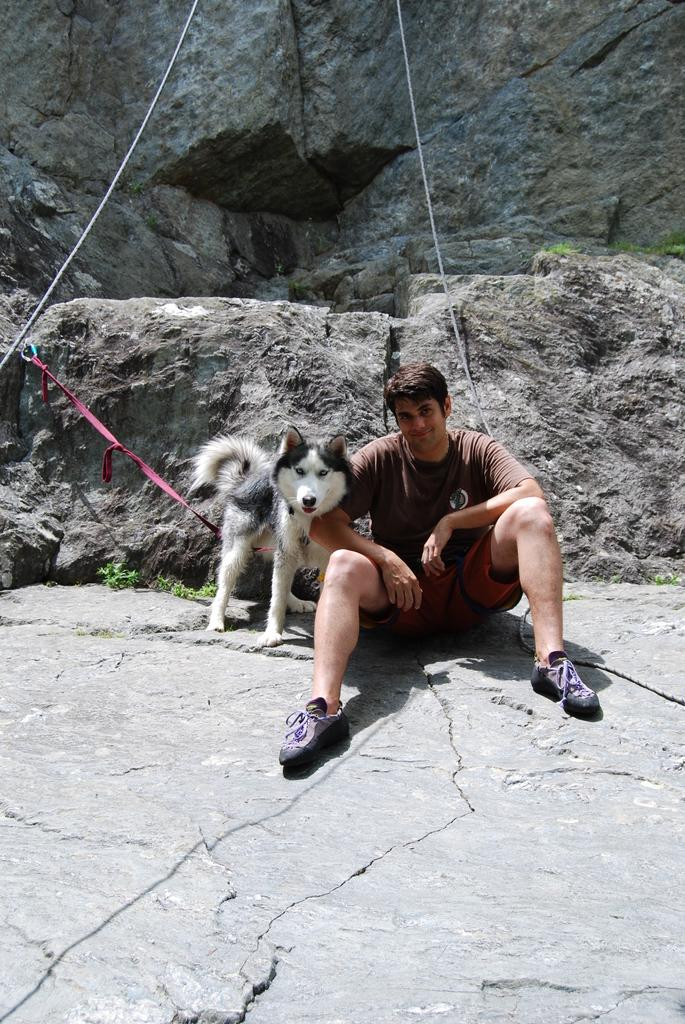Who is present in the image? There is a person in the image. What is the person wearing on their feet? The person is wearing shoes. Where is the person sitting? The person is sitting on a rock. What other living creature is in the image? There is a dog in the image. How is the dog connected to the rock? The dog has a leash connected to the rock. What type of quince can be seen on the shelf in the image? There is no shelf or quince present in the image. What is the name of the downtown area visible in the image? There is no downtown area visible in the image. 